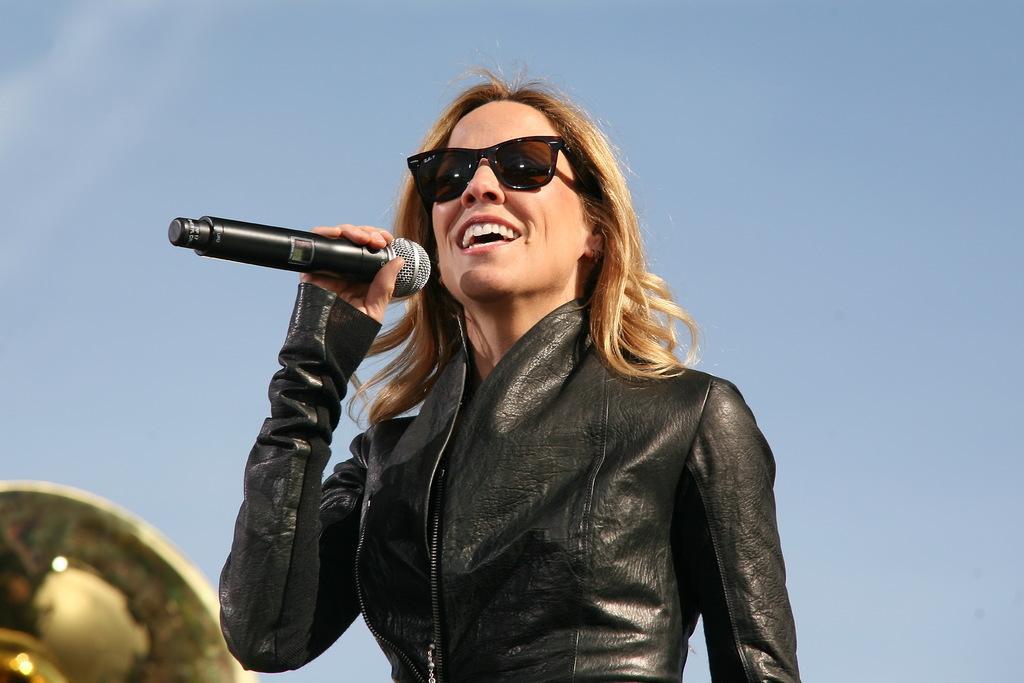Could you give a brief overview of what you see in this image? In this image there is a lady person who is wearing a black color jacket and also spectacles holding a microphone and at the left side of the image there is an object and at the top of the image there is a clear sky. 